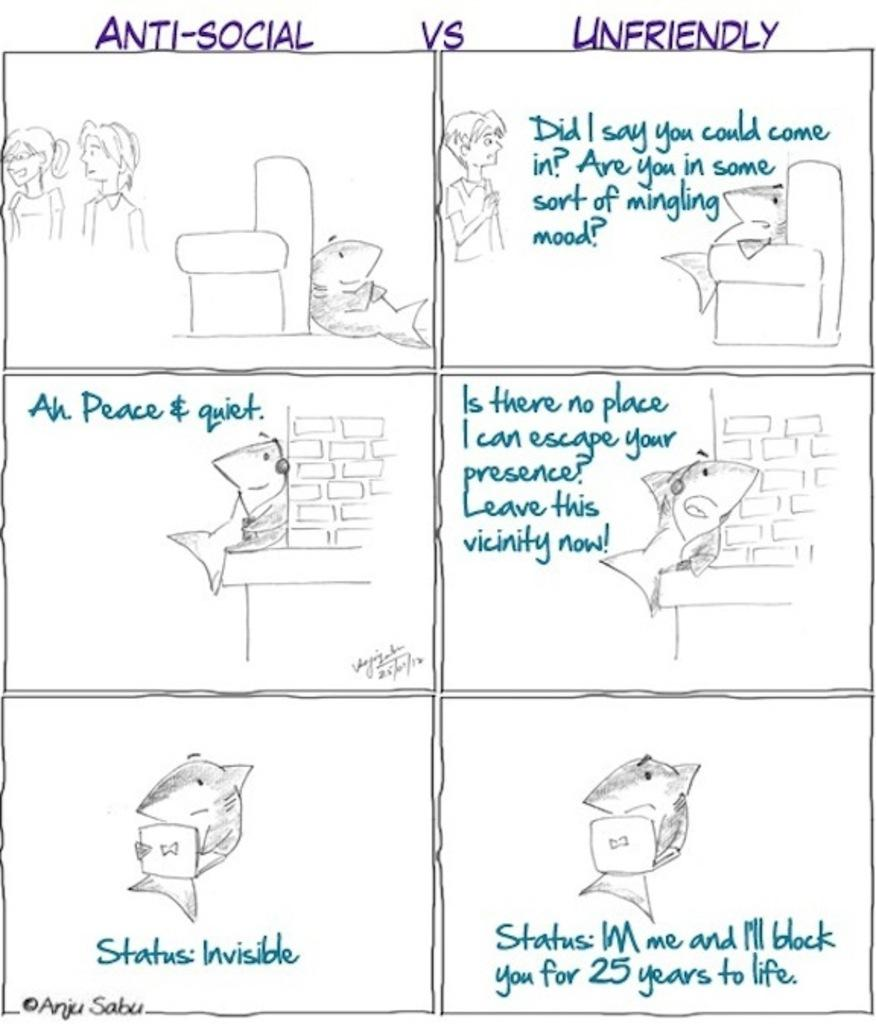What type of image is being described? The image is an edited picture. What kind of drawings can be seen in the image? There are drawings of persons, fish, a wall, and other objects in the image. Are there any text elements in the image? Yes, there are words and numbers in the image. What is the limit of air in the image? There is no mention of air or a limit in the image; it primarily consists of drawings and text elements. 